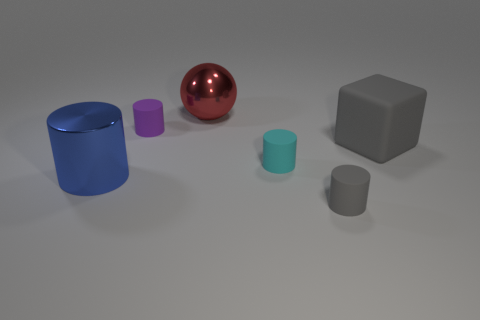Are there any other things that are the same color as the metal cylinder?
Provide a succinct answer. No. Is the number of small rubber cylinders behind the blue metal object greater than the number of brown matte cylinders?
Your answer should be very brief. Yes. There is a tiny thing that is on the left side of the big red shiny sphere; is its shape the same as the large gray object?
Ensure brevity in your answer.  No. There is a object that is behind the purple object; what is its material?
Ensure brevity in your answer.  Metal. How many tiny red metal things are the same shape as the small gray thing?
Keep it short and to the point. 0. There is a large object that is left of the shiny thing that is behind the blue metallic thing; what is its material?
Provide a succinct answer. Metal. There is a small thing that is the same color as the big matte thing; what shape is it?
Your answer should be very brief. Cylinder. Are there any other small cylinders made of the same material as the tiny cyan cylinder?
Provide a succinct answer. Yes. There is a large blue metallic thing; what shape is it?
Keep it short and to the point. Cylinder. How many large red balls are there?
Your answer should be very brief. 1. 